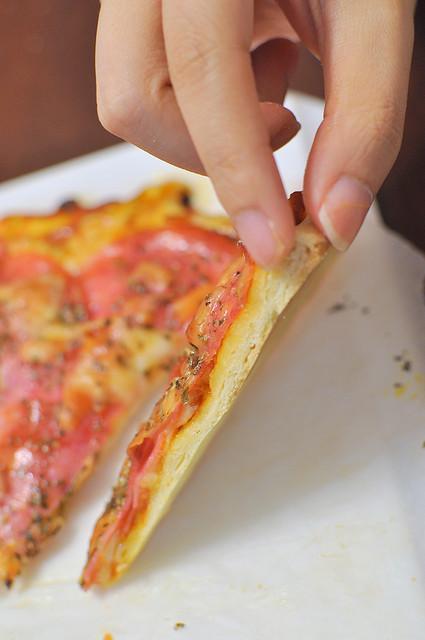How many umbrellas are seen?
Give a very brief answer. 0. 